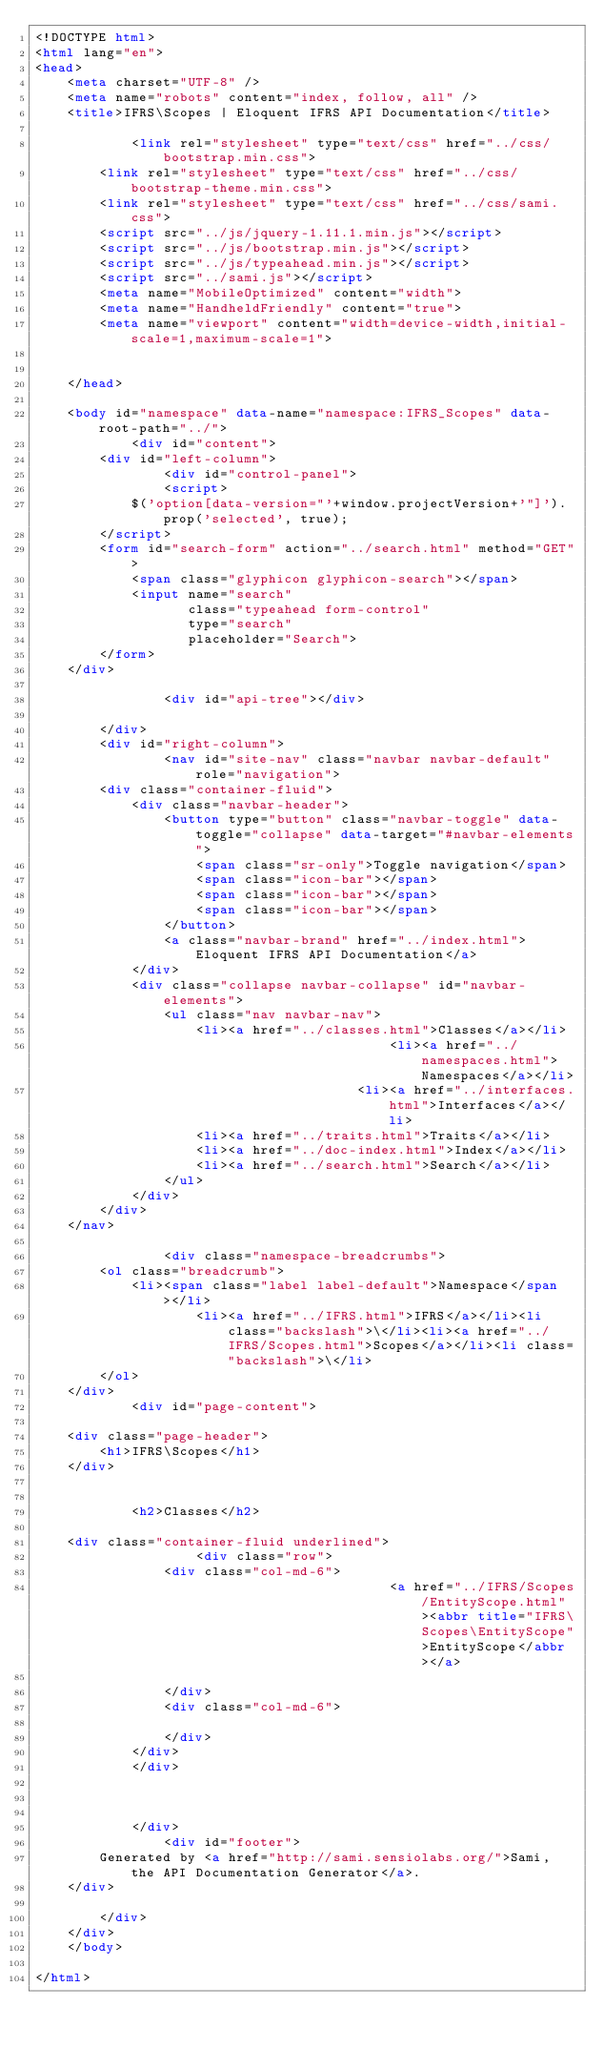<code> <loc_0><loc_0><loc_500><loc_500><_HTML_><!DOCTYPE html>
<html lang="en">
<head>
    <meta charset="UTF-8" />
    <meta name="robots" content="index, follow, all" />
    <title>IFRS\Scopes | Eloquent IFRS API Documentation</title>

            <link rel="stylesheet" type="text/css" href="../css/bootstrap.min.css">
        <link rel="stylesheet" type="text/css" href="../css/bootstrap-theme.min.css">
        <link rel="stylesheet" type="text/css" href="../css/sami.css">
        <script src="../js/jquery-1.11.1.min.js"></script>
        <script src="../js/bootstrap.min.js"></script>
        <script src="../js/typeahead.min.js"></script>
        <script src="../sami.js"></script>
        <meta name="MobileOptimized" content="width">
        <meta name="HandheldFriendly" content="true">
        <meta name="viewport" content="width=device-width,initial-scale=1,maximum-scale=1">
    
    
    </head>

    <body id="namespace" data-name="namespace:IFRS_Scopes" data-root-path="../">
            <div id="content">
        <div id="left-column">
                <div id="control-panel">
                <script>
            $('option[data-version="'+window.projectVersion+'"]').prop('selected', true);
        </script>
        <form id="search-form" action="../search.html" method="GET">
            <span class="glyphicon glyphicon-search"></span>
            <input name="search"
                   class="typeahead form-control"
                   type="search"
                   placeholder="Search">
        </form>
    </div>

                <div id="api-tree"></div>

        </div>
        <div id="right-column">
                <nav id="site-nav" class="navbar navbar-default" role="navigation">
        <div class="container-fluid">
            <div class="navbar-header">
                <button type="button" class="navbar-toggle" data-toggle="collapse" data-target="#navbar-elements">
                    <span class="sr-only">Toggle navigation</span>
                    <span class="icon-bar"></span>
                    <span class="icon-bar"></span>
                    <span class="icon-bar"></span>
                </button>
                <a class="navbar-brand" href="../index.html">Eloquent IFRS API Documentation</a>
            </div>
            <div class="collapse navbar-collapse" id="navbar-elements">
                <ul class="nav navbar-nav">
                    <li><a href="../classes.html">Classes</a></li>
                                            <li><a href="../namespaces.html">Namespaces</a></li>
                                        <li><a href="../interfaces.html">Interfaces</a></li>
                    <li><a href="../traits.html">Traits</a></li>
                    <li><a href="../doc-index.html">Index</a></li>
                    <li><a href="../search.html">Search</a></li>
                </ul>
            </div>
        </div>
    </nav>

                <div class="namespace-breadcrumbs">
        <ol class="breadcrumb">
            <li><span class="label label-default">Namespace</span></li>
                    <li><a href="../IFRS.html">IFRS</a></li><li class="backslash">\</li><li><a href="../IFRS/Scopes.html">Scopes</a></li><li class="backslash">\</li>
        </ol>
    </div>
            <div id="page-content">
                
    <div class="page-header">
        <h1>IFRS\Scopes</h1>
    </div>

    
            <h2>Classes</h2>
        
    <div class="container-fluid underlined">
                    <div class="row">
                <div class="col-md-6">
                                            <a href="../IFRS/Scopes/EntityScope.html"><abbr title="IFRS\Scopes\EntityScope">EntityScope</abbr></a>
                                            
                </div>
                <div class="col-md-6">
                    
                </div>
            </div>
            </div>
    
    
    
            </div>
                <div id="footer">
        Generated by <a href="http://sami.sensiolabs.org/">Sami, the API Documentation Generator</a>.
    </div>

        </div>
    </div>
    </body>

</html>
</code> 